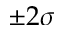Convert formula to latex. <formula><loc_0><loc_0><loc_500><loc_500>\pm 2 \sigma</formula> 